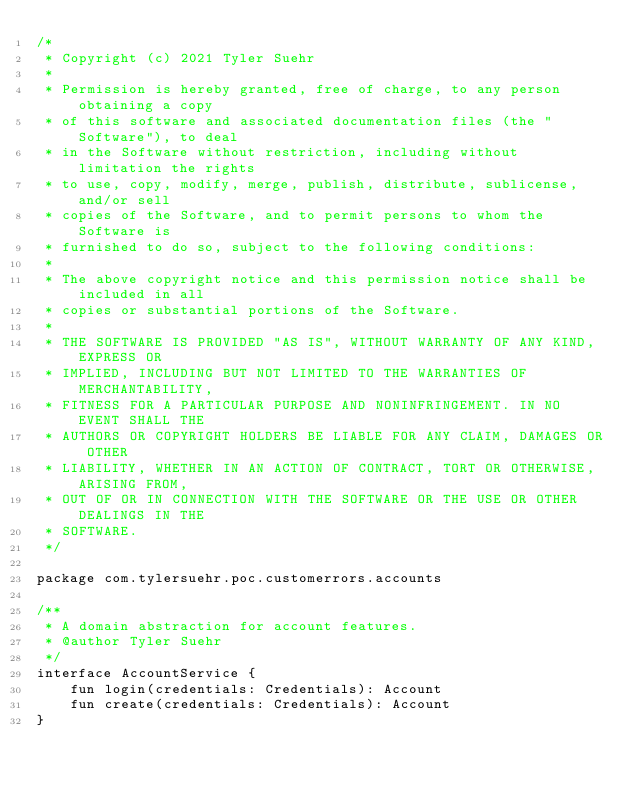Convert code to text. <code><loc_0><loc_0><loc_500><loc_500><_Kotlin_>/*
 * Copyright (c) 2021 Tyler Suehr
 *
 * Permission is hereby granted, free of charge, to any person obtaining a copy
 * of this software and associated documentation files (the "Software"), to deal
 * in the Software without restriction, including without limitation the rights
 * to use, copy, modify, merge, publish, distribute, sublicense, and/or sell
 * copies of the Software, and to permit persons to whom the Software is
 * furnished to do so, subject to the following conditions:
 *
 * The above copyright notice and this permission notice shall be included in all
 * copies or substantial portions of the Software.
 *
 * THE SOFTWARE IS PROVIDED "AS IS", WITHOUT WARRANTY OF ANY KIND, EXPRESS OR
 * IMPLIED, INCLUDING BUT NOT LIMITED TO THE WARRANTIES OF MERCHANTABILITY,
 * FITNESS FOR A PARTICULAR PURPOSE AND NONINFRINGEMENT. IN NO EVENT SHALL THE
 * AUTHORS OR COPYRIGHT HOLDERS BE LIABLE FOR ANY CLAIM, DAMAGES OR OTHER
 * LIABILITY, WHETHER IN AN ACTION OF CONTRACT, TORT OR OTHERWISE, ARISING FROM,
 * OUT OF OR IN CONNECTION WITH THE SOFTWARE OR THE USE OR OTHER DEALINGS IN THE
 * SOFTWARE.
 */

package com.tylersuehr.poc.customerrors.accounts

/**
 * A domain abstraction for account features.
 * @author Tyler Suehr
 */
interface AccountService {
    fun login(credentials: Credentials): Account
    fun create(credentials: Credentials): Account
}
</code> 